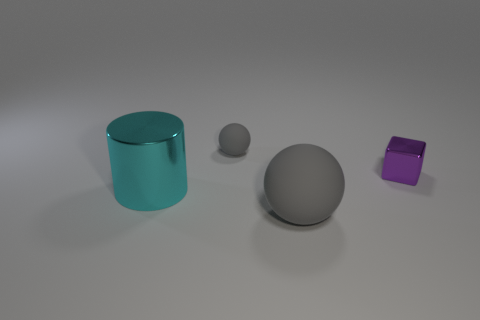Is the shape of the small purple metal thing the same as the small matte thing?
Your response must be concise. No. Is there a big gray thing of the same shape as the small gray rubber thing?
Your response must be concise. Yes. There is a small object that is in front of the matte sphere that is behind the big cyan cylinder; what is its shape?
Your response must be concise. Cube. There is a metallic thing that is in front of the purple cube; what color is it?
Your answer should be compact. Cyan. What size is the cyan cylinder that is made of the same material as the tiny purple thing?
Your answer should be very brief. Large. There is another matte object that is the same shape as the small matte thing; what size is it?
Give a very brief answer. Large. Are any blue matte spheres visible?
Your answer should be compact. No. How many objects are either metallic objects in front of the block or large purple metal objects?
Offer a terse response. 1. There is a rubber ball behind the purple metal object right of the cyan metallic thing; what is its color?
Your answer should be compact. Gray. There is a cyan shiny object; what number of large objects are behind it?
Offer a very short reply. 0. 